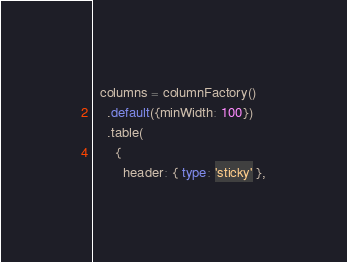Convert code to text. <code><loc_0><loc_0><loc_500><loc_500><_TypeScript_>  columns = columnFactory()
    .default({minWidth: 100})
    .table(
      {
        header: { type: 'sticky' },</code> 